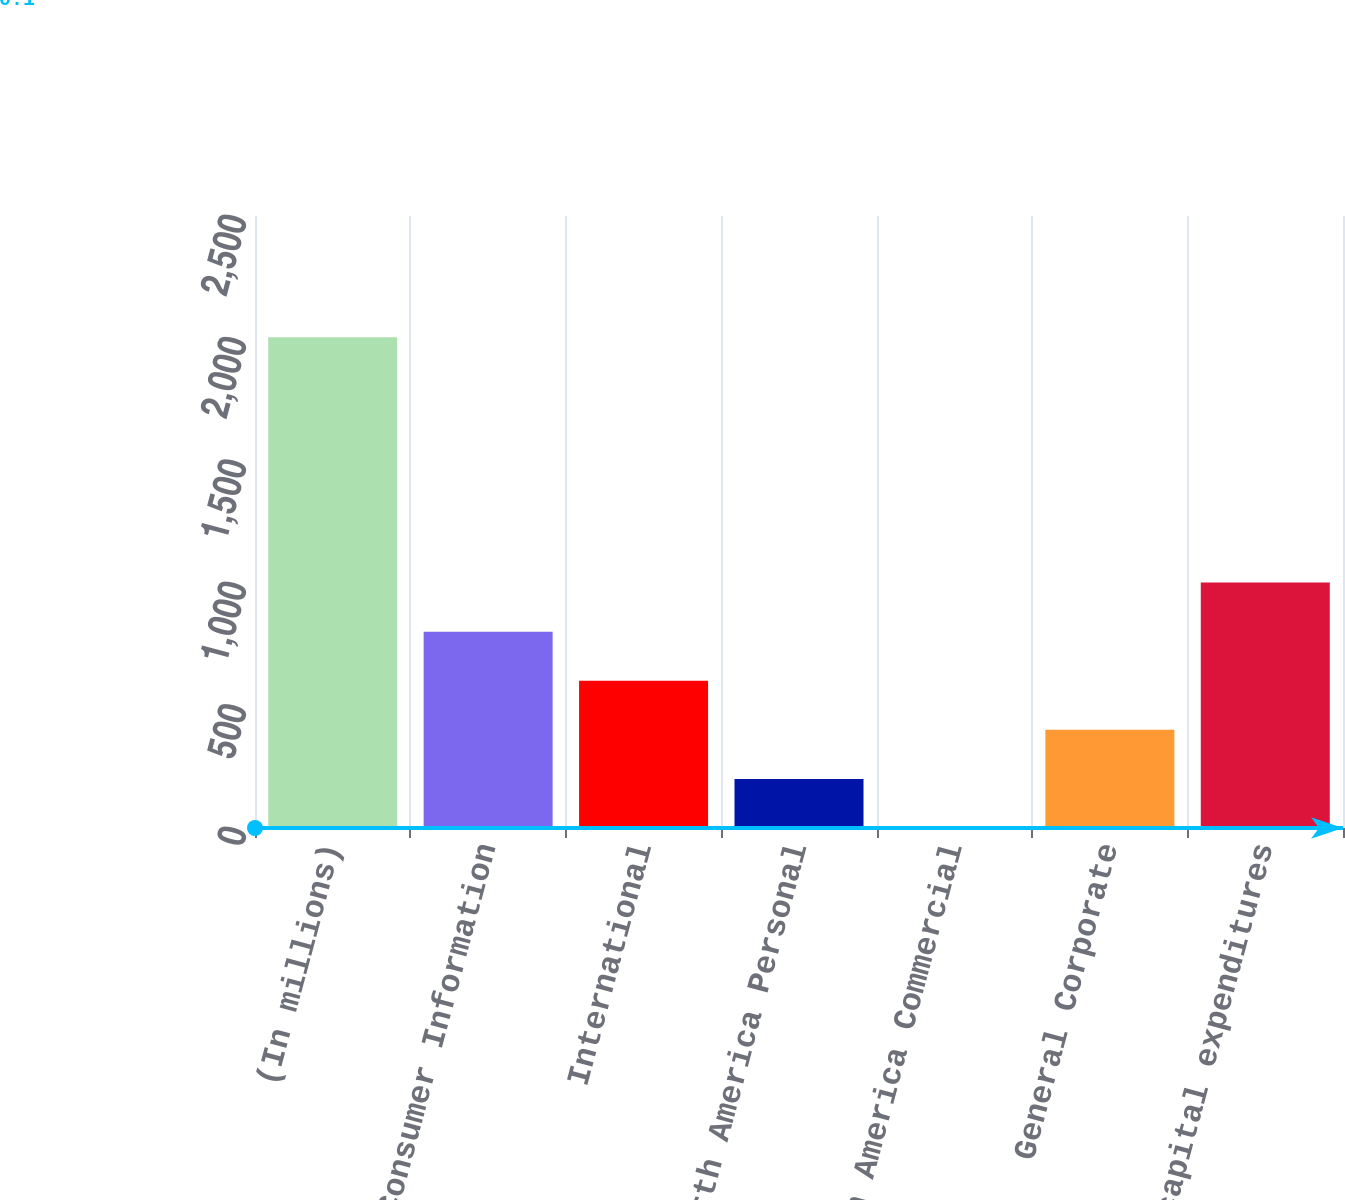Convert chart to OTSL. <chart><loc_0><loc_0><loc_500><loc_500><bar_chart><fcel>(In millions)<fcel>US Consumer Information<fcel>International<fcel>North America Personal<fcel>North America Commercial<fcel>General Corporate<fcel>Total capital expenditures<nl><fcel>2005<fcel>802.06<fcel>601.57<fcel>200.59<fcel>0.1<fcel>401.08<fcel>1002.55<nl></chart> 